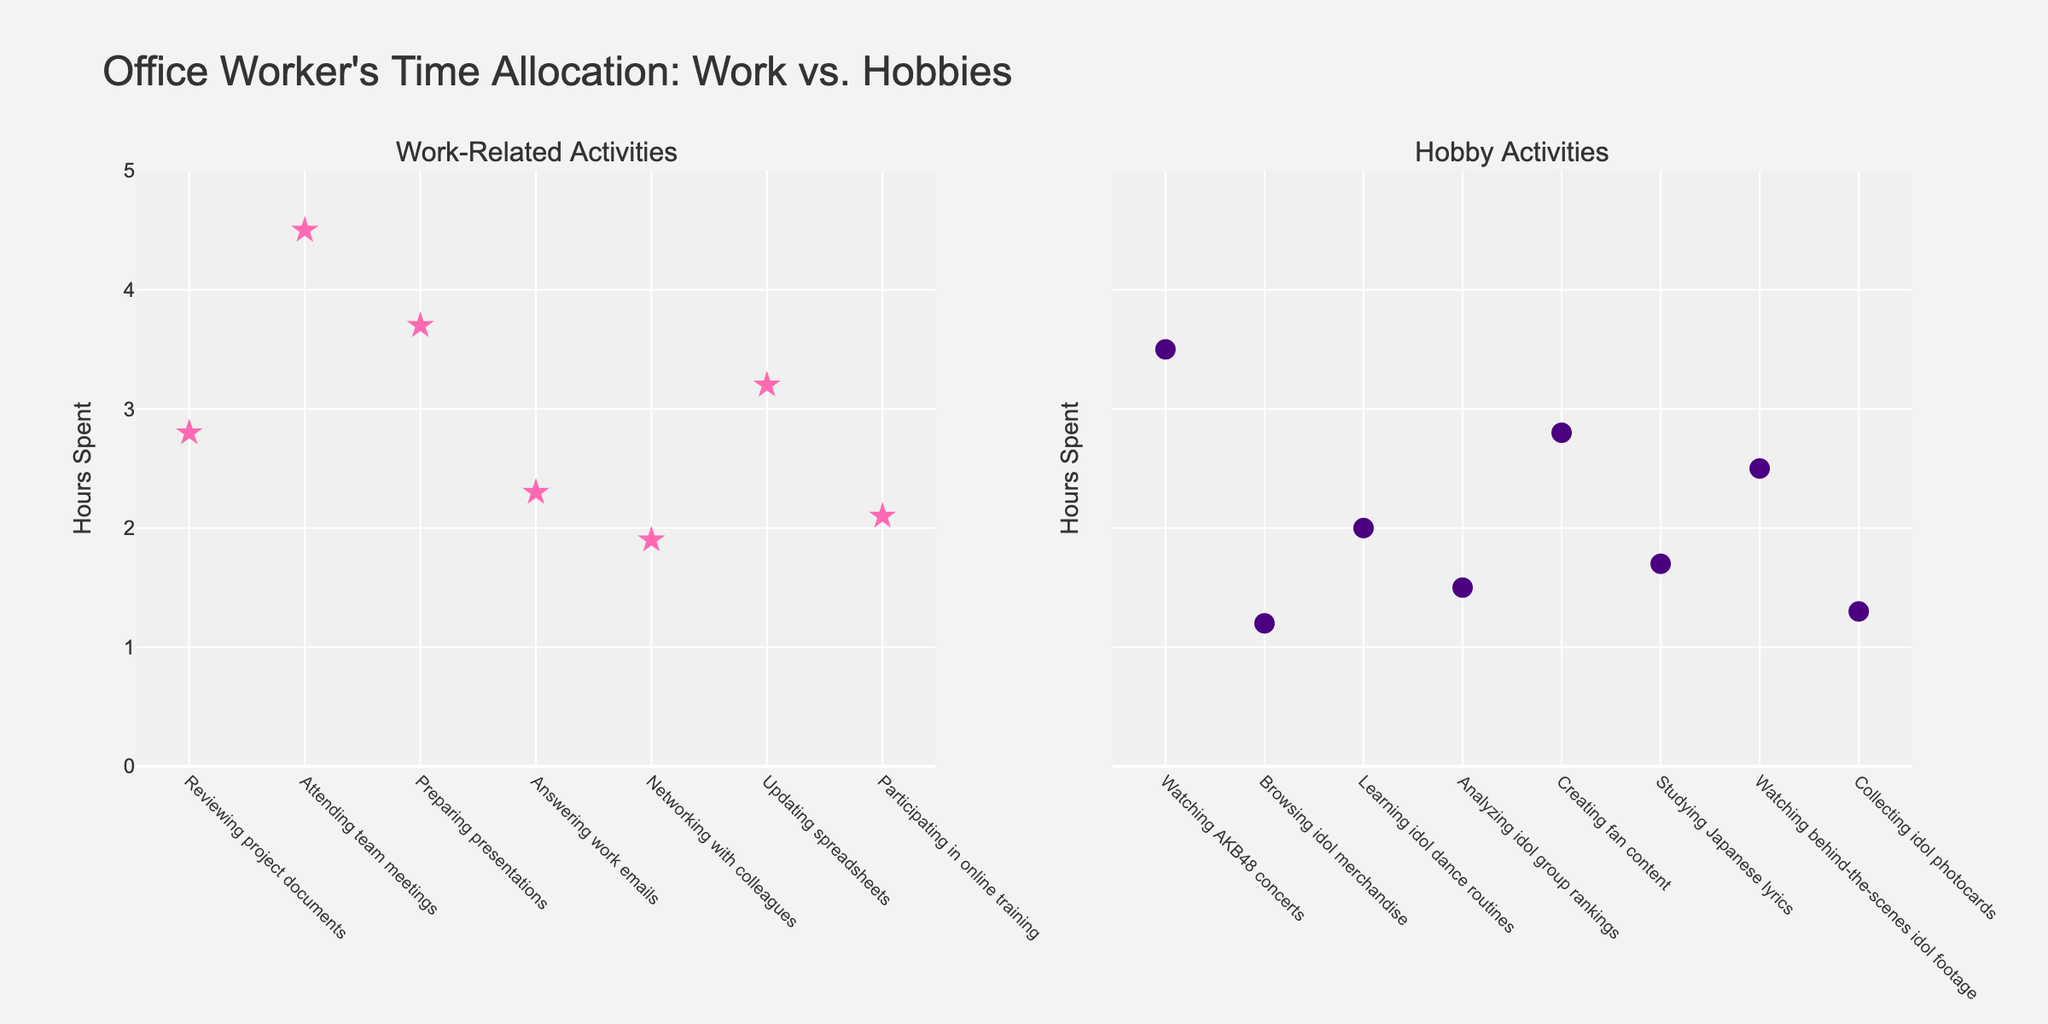What's the title of the figure? The title of the figure is usually found at the top and it describes the content of the visualization. Here, the title reads "Office Worker's Time Allocation: Work vs. Hobbies".
Answer: Office Worker's Time Allocation: Work vs. Hobbies How many activities are plotted on the Work-Related Activities subplot? Count the number of unique data points on the left subplot which is titled "Work-Related Activities". Each point represents one activity.
Answer: 7 What is the range of hours spent on Hobby Activities? Look at the y-axis range on the subplot titled "Hobby Activities". Observe the highest and lowest points on this subplot. The range is from 0 to the maximum value on the y-axis.
Answer: 0 to 4.5 hours Which activity in the Hobby Activities subplot has the highest hours spent? Look for the point that is the highest on the y-axis in the subplot titled "Hobby Activities". The label on the x-axis corresponding to this highest point will indicate the activity.
Answer: Watching AKB48 concerts How does the time spent on "Attending team meetings" compare to "Preparing presentations"? Locate the points for "Attending team meetings" and "Preparing presentations" in the Work-Related Activities subplot. Compare their y-axis values directly to determine which has more hours spent.
Answer: Attending team meetings has more hours spent What is the average time spent on all Work-Related Activities? Sum the hours spent on all activities within the Work-Related subplot and divide by the number of activities to find the average. (2.8 + 4.5 + 3.7 + 2.3 + 1.9 + 3.2 + 2.1)/7.
Answer: 2.93 hours What is the total time spent on Hobby Activities? Sum the hours spent on all activities within the Hobby Activities subplot to find the total. (3.5 + 1.2 + 2.0 + 1.5 + 2.8 + 1.7 + 2.5 + 1.3).
Answer: 16.5 hours Which subplot has a broader range of hours spent, and what is the range for each? Compare the y-axis ranges of both subplots. The range for each is the difference between the maximum and minimum values on the y-axis. For Work-Related Activities, range is (4.5 - 2.1) = 2.4. For Hobby Activities, range is (3.5 - 1.2) = 2.3. The broader range is Work-Related.
Answer: Work-Related Activities, 2.4 hours Is there an activity in both subplots that has exactly 2.8 hours spent? Examine both subplots to identify if any markers align with the 2.8-hour tick mark on the y-axis, and check if there is any corresponding activity.
Answer: Yes 